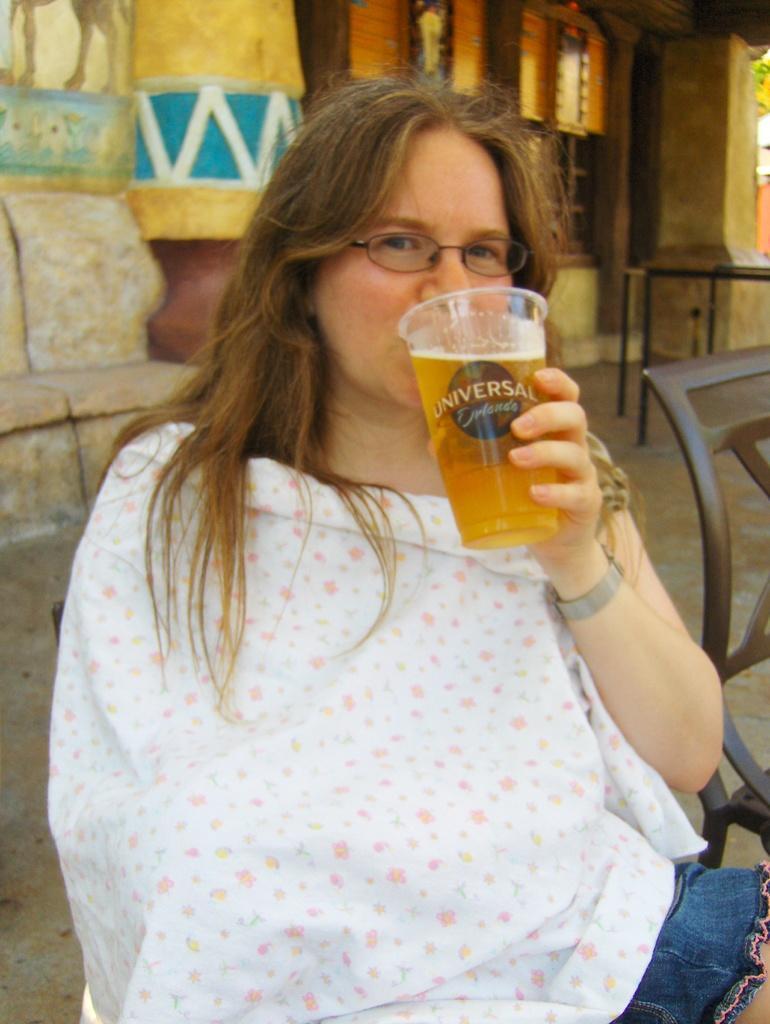How would you summarize this image in a sentence or two? This woman wore white dress, spectacles and drinking juice from this glass. At background there is a building with window. Beside this woman there is a chair. 